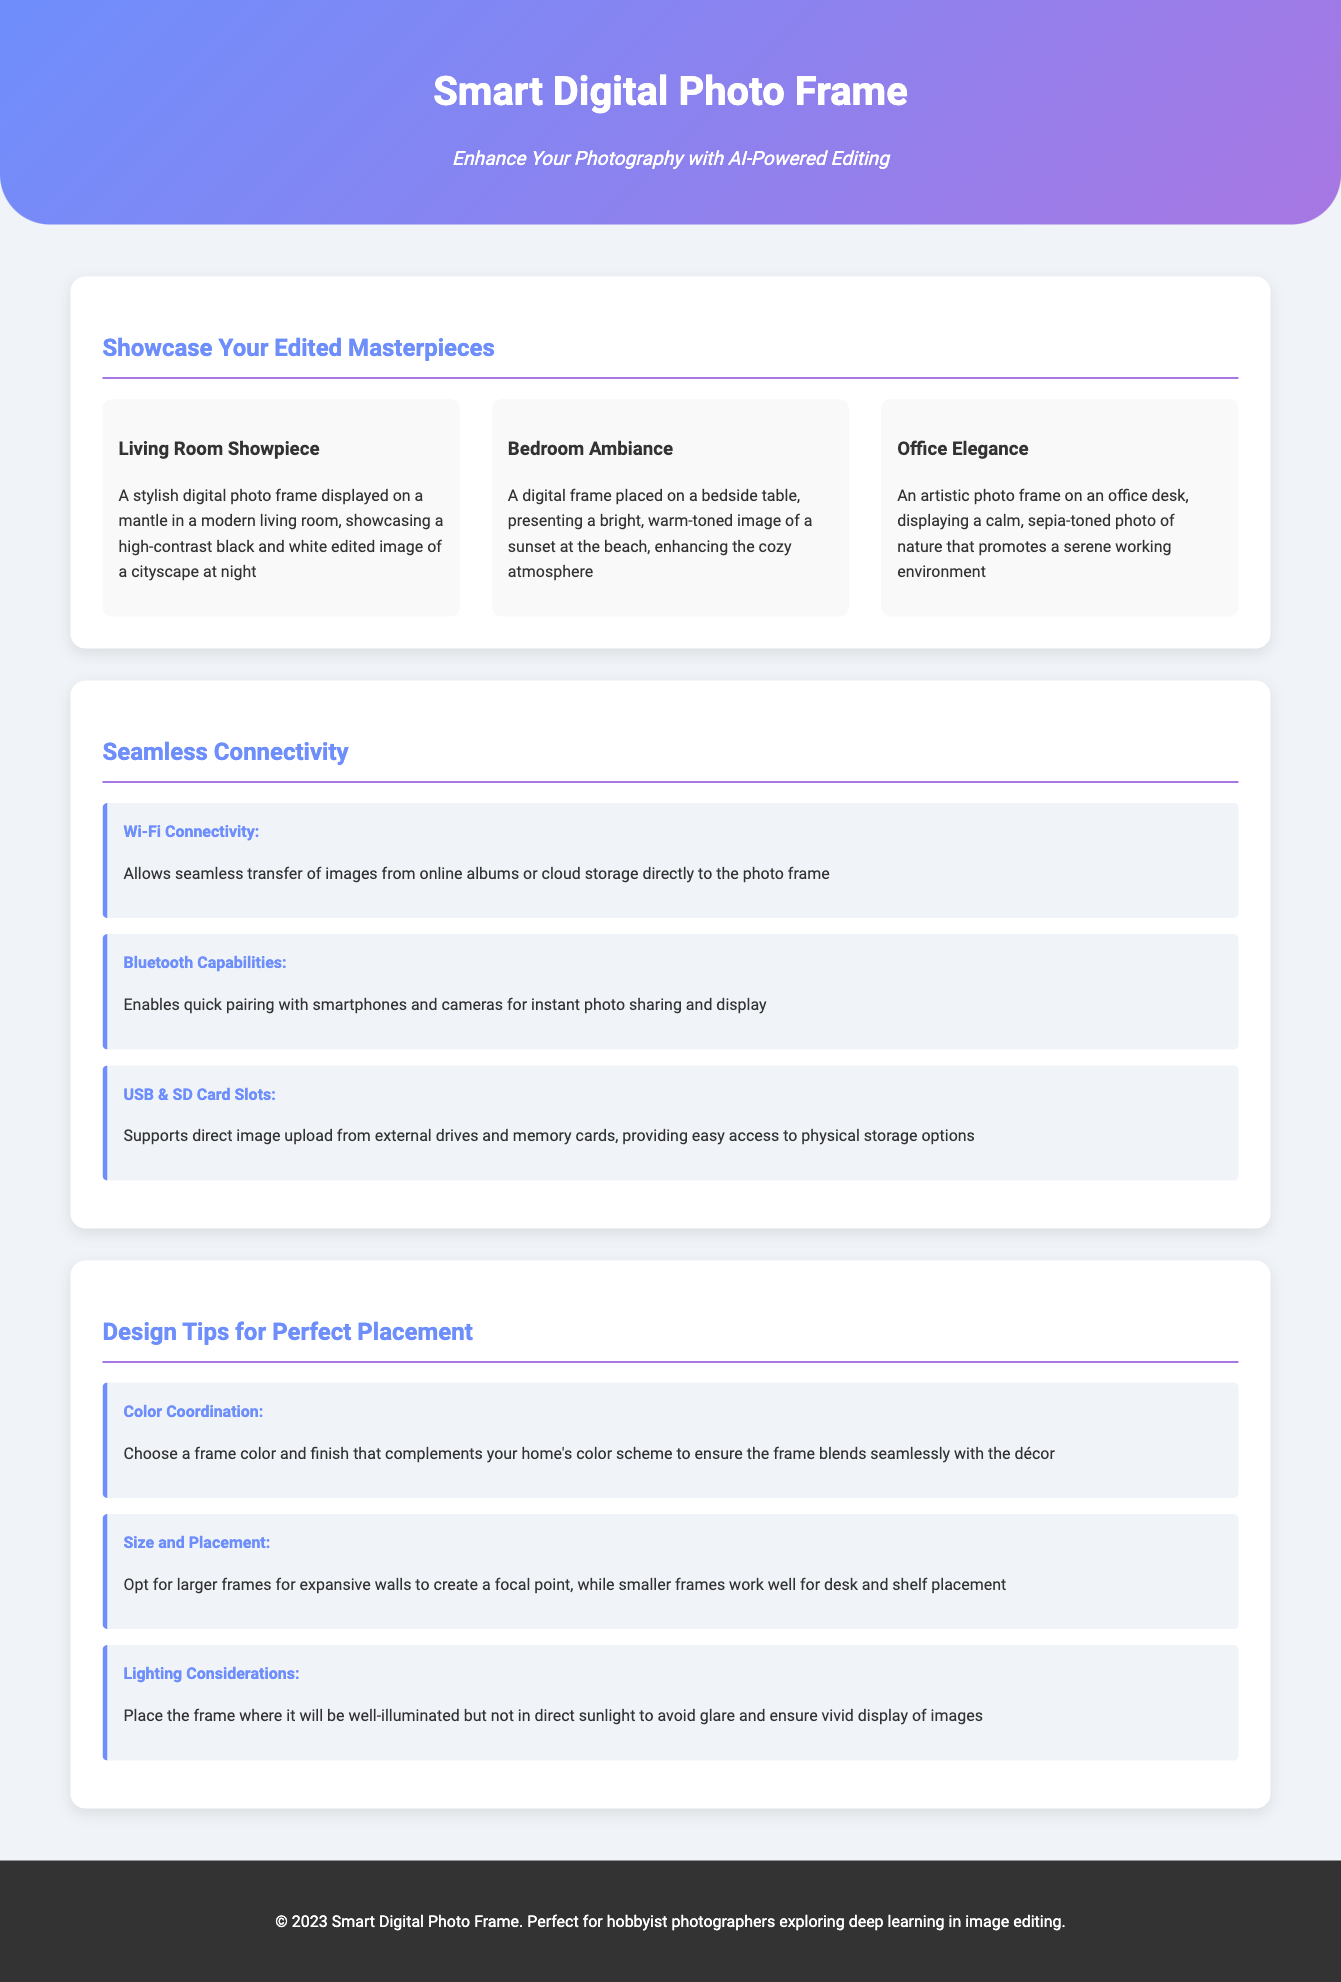What is the title of the product? The title of the product is mentioned in the header section of the document.
Answer: Smart Digital Photo Frame How many mockup items are displayed in the document? The document showcases three mockup items under the section "Showcase Your Edited Masterpieces."
Answer: Three What feature enhances photo transfer from online albums? The feature that enhances photo transfer from online albums is identified in the "Seamless Connectivity" section.
Answer: Wi-Fi Connectivity What design tip advises placement considering sunlight? The design tip that advises placement considering sunlight is included in the "Design Tips for Perfect Placement" section.
Answer: Lighting Considerations Which image tone is highlighted in the "Office Elegance" mockup? The tone highlighted in the "Office Elegance" mockup is stated in the description of the item.
Answer: Sepia-toned What color scheme is recommended for the frame? The recommendation for the frame's color scheme is provided in the "Design Tips for Perfect Placement" section.
Answer: Complements your home's color scheme How many connectivity features are listed? The document contains a list of connectivity features in the "Seamless Connectivity" section.
Answer: Three What should you consider for larger walls? The consideration for larger walls is addressed in the "Design Tips for Perfect Placement" section.
Answer: Larger frames to create a focal point Which photo type is suggested for the bedroom ambiance? The suggested photo type for the bedroom ambiance is described in the "Bedroom Ambiance" mockup.
Answer: Bright, warm-toned image What is the footer's copyright year? The copyright year found in the footer of the document indicates the publication date.
Answer: 2023 